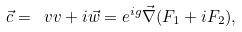<formula> <loc_0><loc_0><loc_500><loc_500>\vec { c } = \ v v + i \vec { w } = e ^ { i g } \vec { \nabla } ( F _ { 1 } + i F _ { 2 } ) ,</formula> 